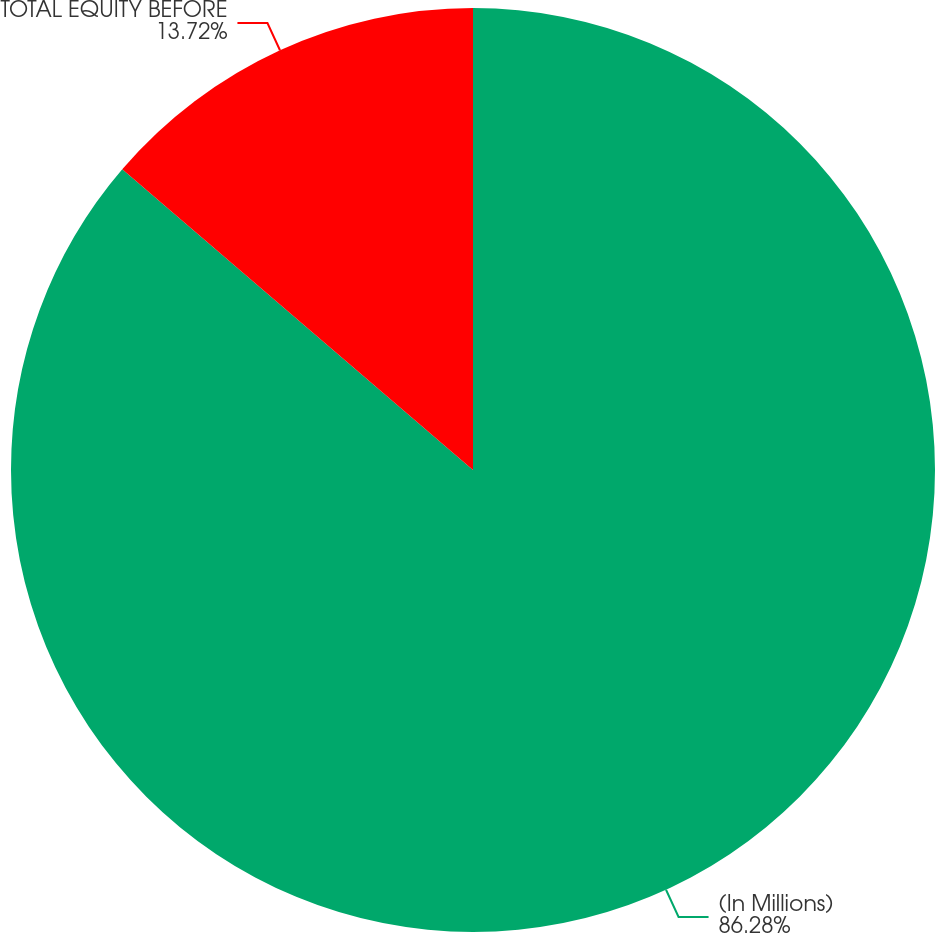Convert chart to OTSL. <chart><loc_0><loc_0><loc_500><loc_500><pie_chart><fcel>(In Millions)<fcel>TOTAL EQUITY BEFORE<nl><fcel>86.28%<fcel>13.72%<nl></chart> 